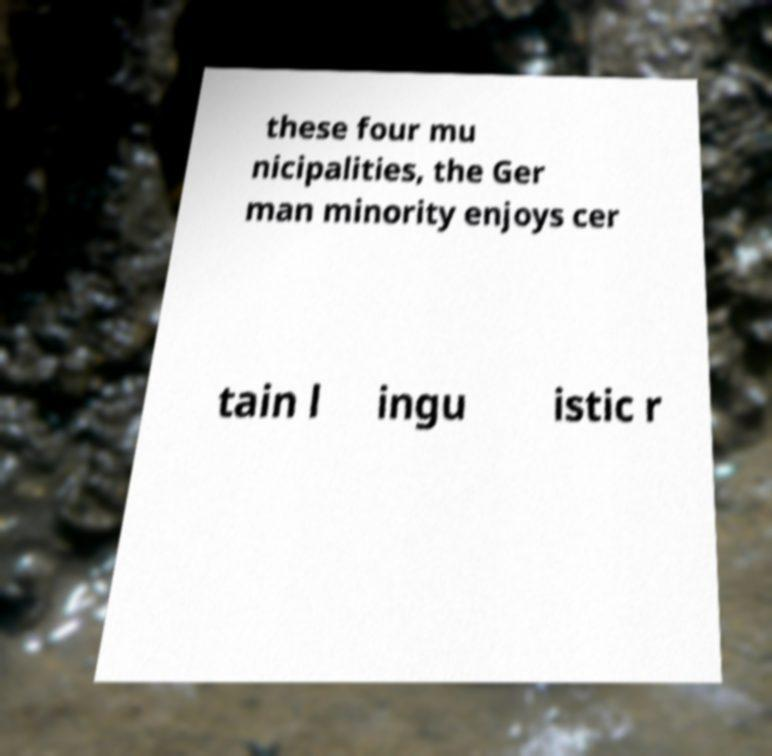Could you extract and type out the text from this image? these four mu nicipalities, the Ger man minority enjoys cer tain l ingu istic r 